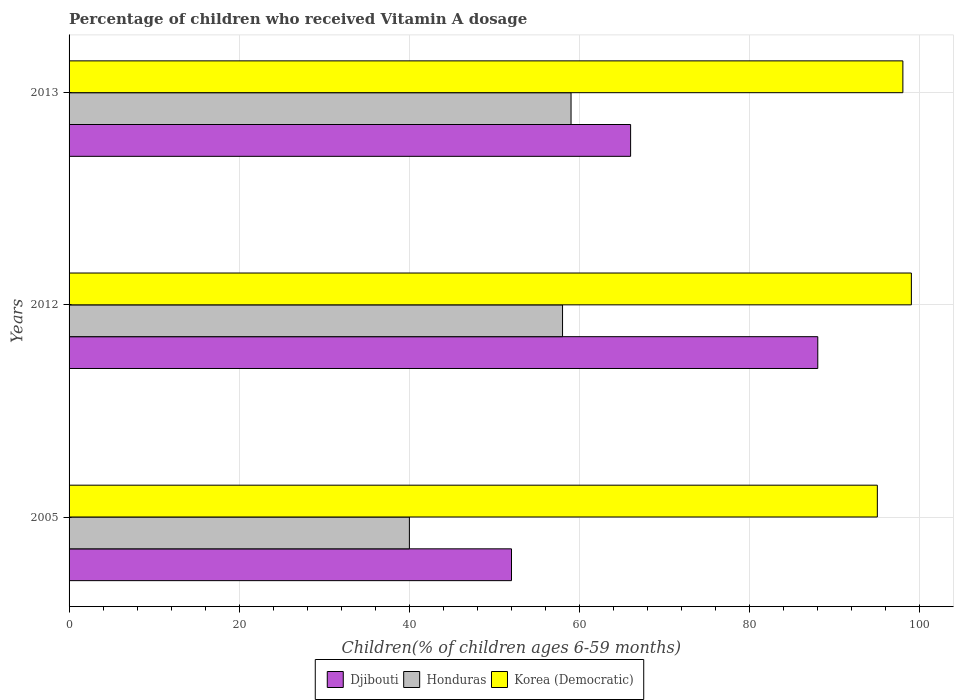How many different coloured bars are there?
Give a very brief answer. 3. Are the number of bars per tick equal to the number of legend labels?
Offer a very short reply. Yes. Are the number of bars on each tick of the Y-axis equal?
Provide a short and direct response. Yes. What is the label of the 2nd group of bars from the top?
Ensure brevity in your answer.  2012. In how many cases, is the number of bars for a given year not equal to the number of legend labels?
Offer a terse response. 0. What is the percentage of children who received Vitamin A dosage in Honduras in 2005?
Ensure brevity in your answer.  40. In which year was the percentage of children who received Vitamin A dosage in Djibouti maximum?
Your answer should be compact. 2012. What is the total percentage of children who received Vitamin A dosage in Honduras in the graph?
Give a very brief answer. 157. What is the difference between the percentage of children who received Vitamin A dosage in Korea (Democratic) in 2005 and the percentage of children who received Vitamin A dosage in Djibouti in 2013?
Provide a succinct answer. 29. What is the average percentage of children who received Vitamin A dosage in Honduras per year?
Ensure brevity in your answer.  52.33. In the year 2012, what is the difference between the percentage of children who received Vitamin A dosage in Korea (Democratic) and percentage of children who received Vitamin A dosage in Honduras?
Provide a short and direct response. 41. In how many years, is the percentage of children who received Vitamin A dosage in Djibouti greater than 68 %?
Provide a succinct answer. 1. What is the ratio of the percentage of children who received Vitamin A dosage in Djibouti in 2005 to that in 2012?
Keep it short and to the point. 0.59. What is the difference between the highest and the second highest percentage of children who received Vitamin A dosage in Korea (Democratic)?
Offer a very short reply. 1. What is the difference between the highest and the lowest percentage of children who received Vitamin A dosage in Korea (Democratic)?
Ensure brevity in your answer.  4. In how many years, is the percentage of children who received Vitamin A dosage in Djibouti greater than the average percentage of children who received Vitamin A dosage in Djibouti taken over all years?
Give a very brief answer. 1. What does the 3rd bar from the top in 2005 represents?
Offer a terse response. Djibouti. What does the 2nd bar from the bottom in 2013 represents?
Your response must be concise. Honduras. Is it the case that in every year, the sum of the percentage of children who received Vitamin A dosage in Honduras and percentage of children who received Vitamin A dosage in Korea (Democratic) is greater than the percentage of children who received Vitamin A dosage in Djibouti?
Keep it short and to the point. Yes. Are all the bars in the graph horizontal?
Provide a short and direct response. Yes. How many years are there in the graph?
Ensure brevity in your answer.  3. What is the difference between two consecutive major ticks on the X-axis?
Offer a very short reply. 20. Are the values on the major ticks of X-axis written in scientific E-notation?
Provide a succinct answer. No. Does the graph contain grids?
Offer a very short reply. Yes. Where does the legend appear in the graph?
Your answer should be very brief. Bottom center. How many legend labels are there?
Offer a terse response. 3. How are the legend labels stacked?
Give a very brief answer. Horizontal. What is the title of the graph?
Your answer should be very brief. Percentage of children who received Vitamin A dosage. Does "Uzbekistan" appear as one of the legend labels in the graph?
Your response must be concise. No. What is the label or title of the X-axis?
Give a very brief answer. Children(% of children ages 6-59 months). What is the Children(% of children ages 6-59 months) in Djibouti in 2005?
Your response must be concise. 52. What is the Children(% of children ages 6-59 months) of Honduras in 2005?
Ensure brevity in your answer.  40. What is the Children(% of children ages 6-59 months) in Djibouti in 2012?
Ensure brevity in your answer.  88. What is the Children(% of children ages 6-59 months) in Honduras in 2012?
Your answer should be compact. 58. What is the Children(% of children ages 6-59 months) of Korea (Democratic) in 2012?
Your response must be concise. 99. What is the Children(% of children ages 6-59 months) in Djibouti in 2013?
Your response must be concise. 66. What is the Children(% of children ages 6-59 months) of Korea (Democratic) in 2013?
Provide a short and direct response. 98. Across all years, what is the maximum Children(% of children ages 6-59 months) in Djibouti?
Ensure brevity in your answer.  88. Across all years, what is the maximum Children(% of children ages 6-59 months) of Honduras?
Offer a terse response. 59. Across all years, what is the minimum Children(% of children ages 6-59 months) in Djibouti?
Provide a short and direct response. 52. What is the total Children(% of children ages 6-59 months) of Djibouti in the graph?
Your answer should be very brief. 206. What is the total Children(% of children ages 6-59 months) in Honduras in the graph?
Ensure brevity in your answer.  157. What is the total Children(% of children ages 6-59 months) of Korea (Democratic) in the graph?
Provide a succinct answer. 292. What is the difference between the Children(% of children ages 6-59 months) of Djibouti in 2005 and that in 2012?
Your answer should be compact. -36. What is the difference between the Children(% of children ages 6-59 months) in Honduras in 2005 and that in 2013?
Offer a very short reply. -19. What is the difference between the Children(% of children ages 6-59 months) of Korea (Democratic) in 2005 and that in 2013?
Your response must be concise. -3. What is the difference between the Children(% of children ages 6-59 months) in Djibouti in 2005 and the Children(% of children ages 6-59 months) in Korea (Democratic) in 2012?
Provide a short and direct response. -47. What is the difference between the Children(% of children ages 6-59 months) in Honduras in 2005 and the Children(% of children ages 6-59 months) in Korea (Democratic) in 2012?
Offer a terse response. -59. What is the difference between the Children(% of children ages 6-59 months) of Djibouti in 2005 and the Children(% of children ages 6-59 months) of Korea (Democratic) in 2013?
Provide a succinct answer. -46. What is the difference between the Children(% of children ages 6-59 months) in Honduras in 2005 and the Children(% of children ages 6-59 months) in Korea (Democratic) in 2013?
Provide a short and direct response. -58. What is the average Children(% of children ages 6-59 months) of Djibouti per year?
Your answer should be compact. 68.67. What is the average Children(% of children ages 6-59 months) of Honduras per year?
Offer a terse response. 52.33. What is the average Children(% of children ages 6-59 months) of Korea (Democratic) per year?
Your answer should be very brief. 97.33. In the year 2005, what is the difference between the Children(% of children ages 6-59 months) of Djibouti and Children(% of children ages 6-59 months) of Honduras?
Offer a very short reply. 12. In the year 2005, what is the difference between the Children(% of children ages 6-59 months) of Djibouti and Children(% of children ages 6-59 months) of Korea (Democratic)?
Make the answer very short. -43. In the year 2005, what is the difference between the Children(% of children ages 6-59 months) in Honduras and Children(% of children ages 6-59 months) in Korea (Democratic)?
Provide a succinct answer. -55. In the year 2012, what is the difference between the Children(% of children ages 6-59 months) of Djibouti and Children(% of children ages 6-59 months) of Korea (Democratic)?
Provide a succinct answer. -11. In the year 2012, what is the difference between the Children(% of children ages 6-59 months) in Honduras and Children(% of children ages 6-59 months) in Korea (Democratic)?
Offer a very short reply. -41. In the year 2013, what is the difference between the Children(% of children ages 6-59 months) of Djibouti and Children(% of children ages 6-59 months) of Honduras?
Offer a terse response. 7. In the year 2013, what is the difference between the Children(% of children ages 6-59 months) of Djibouti and Children(% of children ages 6-59 months) of Korea (Democratic)?
Offer a very short reply. -32. In the year 2013, what is the difference between the Children(% of children ages 6-59 months) in Honduras and Children(% of children ages 6-59 months) in Korea (Democratic)?
Give a very brief answer. -39. What is the ratio of the Children(% of children ages 6-59 months) in Djibouti in 2005 to that in 2012?
Provide a short and direct response. 0.59. What is the ratio of the Children(% of children ages 6-59 months) of Honduras in 2005 to that in 2012?
Provide a succinct answer. 0.69. What is the ratio of the Children(% of children ages 6-59 months) in Korea (Democratic) in 2005 to that in 2012?
Your answer should be very brief. 0.96. What is the ratio of the Children(% of children ages 6-59 months) in Djibouti in 2005 to that in 2013?
Your response must be concise. 0.79. What is the ratio of the Children(% of children ages 6-59 months) in Honduras in 2005 to that in 2013?
Give a very brief answer. 0.68. What is the ratio of the Children(% of children ages 6-59 months) of Korea (Democratic) in 2005 to that in 2013?
Provide a succinct answer. 0.97. What is the ratio of the Children(% of children ages 6-59 months) of Djibouti in 2012 to that in 2013?
Make the answer very short. 1.33. What is the ratio of the Children(% of children ages 6-59 months) in Honduras in 2012 to that in 2013?
Ensure brevity in your answer.  0.98. What is the ratio of the Children(% of children ages 6-59 months) in Korea (Democratic) in 2012 to that in 2013?
Your response must be concise. 1.01. What is the difference between the highest and the second highest Children(% of children ages 6-59 months) in Djibouti?
Provide a short and direct response. 22. What is the difference between the highest and the second highest Children(% of children ages 6-59 months) in Honduras?
Make the answer very short. 1. What is the difference between the highest and the second highest Children(% of children ages 6-59 months) of Korea (Democratic)?
Ensure brevity in your answer.  1. What is the difference between the highest and the lowest Children(% of children ages 6-59 months) of Korea (Democratic)?
Ensure brevity in your answer.  4. 